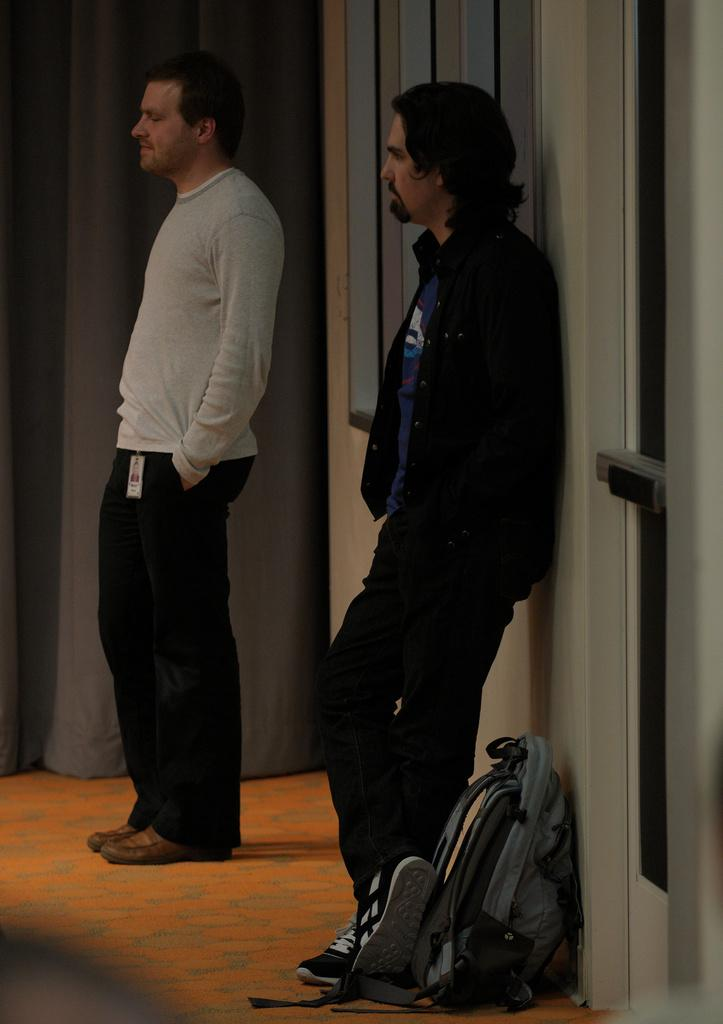How many people are in the image? There are two men standing in the image. What is the surface they are standing on? The men are standing on the floor. What object is placed beside the men? There is a bag placed beside the men. What can be seen in the background of the image? There is a wall, a curtain, and a door visible in the image. What type of road can be seen outside the door in the image? There is no road visible in the image; only a wall, a curtain, and a door are present in the background. 